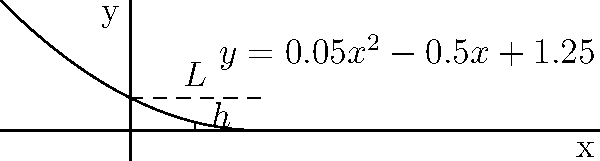As a travel blogger exploring Thailand's architectural wonders, you come across a unique hanging bridge. The cable of this bridge forms a parabolic curve represented by the equation $y = 0.05x^2 - 0.5x + 1.25$, where $x$ and $y$ are measured in meters. The bridge spans a distance of 5 meters between two support towers. What is the maximum depth (h) of the cable below the horizontal line connecting the two support towers? To find the maximum depth of the cable, we need to follow these steps:

1) First, we need to find the vertex of the parabola. For a quadratic function $f(x) = ax^2 + bx + c$, the x-coordinate of the vertex is given by $x = -b/(2a)$.

2) In our case, $a = 0.05$, $b = -0.5$, and $c = 1.25$. Therefore:

   $x = -(-0.5)/(2(0.05)) = 0.5/0.1 = 5$

3) The x-coordinate of the vertex is 5, which coincides with one end of the bridge.

4) To find the lowest point of the cable within the bridge span, we need to evaluate the function at $x = 0$ (left end) and $x = 5$ (right end), and compare:

   At $x = 0$: $y = 0.05(0)^2 - 0.5(0) + 1.25 = 1.25$
   At $x = 5$: $y = 0.05(5)^2 - 0.5(5) + 1.25 = 1.25 - 2.5 + 1.25 = 0$

5) The lowest point is at $x = 5$, where $y = 0$.

6) The maximum depth $h$ is the difference between the y-value at the supports (1.25) and the lowest point (0):

   $h = 1.25 - 0 = 1.25$ meters

Therefore, the maximum depth of the cable below the horizontal line is 1.25 meters.
Answer: 1.25 meters 